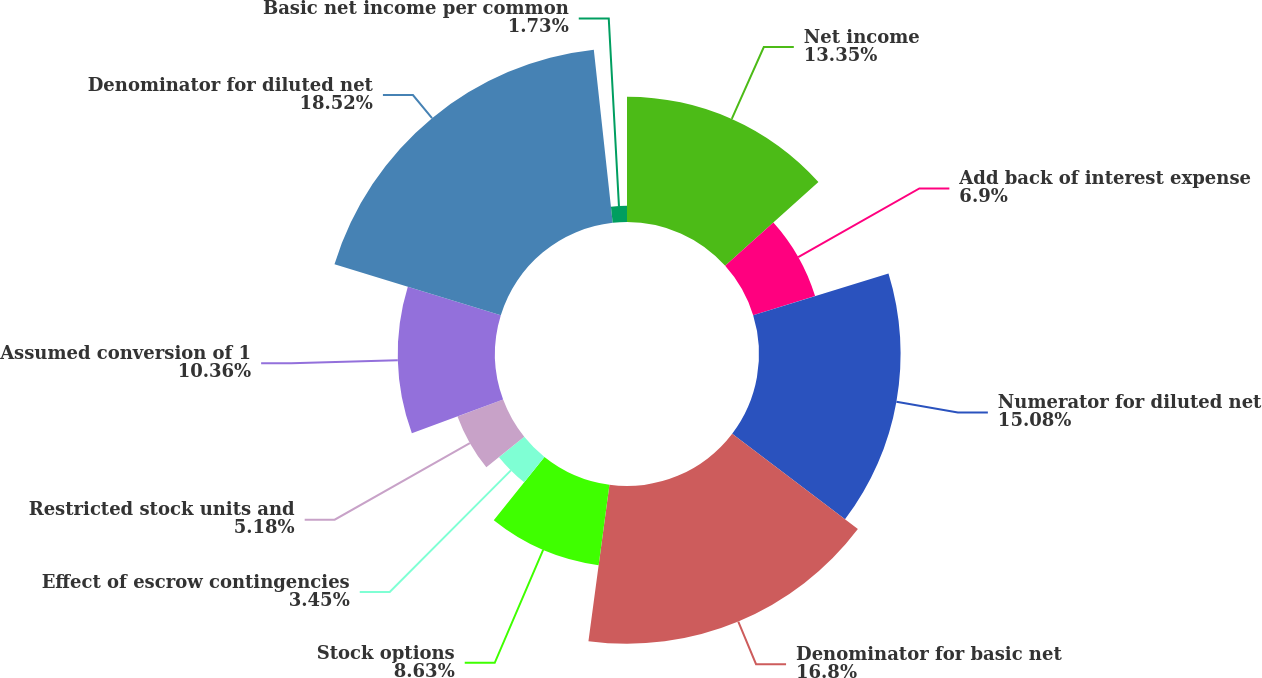Convert chart to OTSL. <chart><loc_0><loc_0><loc_500><loc_500><pie_chart><fcel>Net income<fcel>Add back of interest expense<fcel>Numerator for diluted net<fcel>Denominator for basic net<fcel>Stock options<fcel>Effect of escrow contingencies<fcel>Restricted stock units and<fcel>Assumed conversion of 1<fcel>Denominator for diluted net<fcel>Basic net income per common<nl><fcel>13.35%<fcel>6.9%<fcel>15.08%<fcel>16.8%<fcel>8.63%<fcel>3.45%<fcel>5.18%<fcel>10.36%<fcel>18.53%<fcel>1.73%<nl></chart> 